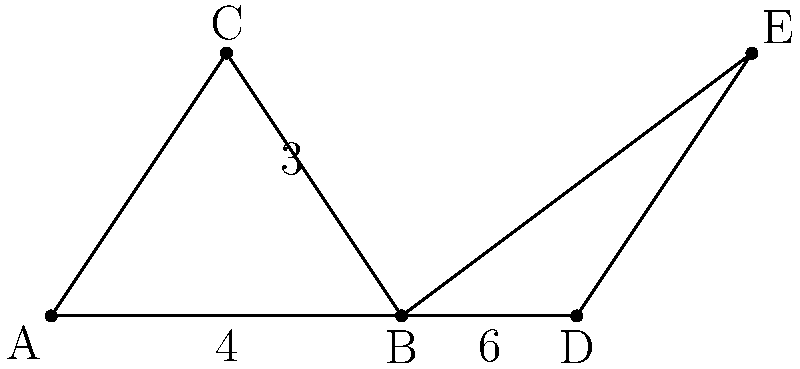During a practice session, you notice that your hockey sticks form two triangles on the ice as shown in the diagram. Triangle ABC and triangle BDE share a common base angle at point B. If AB = 4 units, BC = 3 units, and BD = 6 units, are these triangles congruent? If so, state the congruence criterion. Let's approach this step-by-step:

1) First, we need to determine if these triangles are congruent. For this, we need to check if they satisfy any of the congruence criteria: SSS, SAS, ASA, or AAS.

2) We're given that:
   - AB = 4 units
   - BC = 3 units
   - BD = 6 units
   - Angle B is common to both triangles

3) We don't have enough information about all sides or all angles. However, we can use the given information to prove that these triangles are similar, and then check if they're congruent.

4) The triangles share an angle at B, and both have a right angle (one at A, one at D). Two angles being equal means the triangles are similar.

5) For similar triangles, the ratio of corresponding sides is constant. Let's call this ratio r.

   $r = \frac{BD}{AB} = \frac{6}{4} = 1.5$

6) If the triangles are congruent, this ratio should be 1. Since it's 1.5, the triangles are not congruent.

7) We can confirm this by calculating BE:
   $BE = BC * r = 3 * 1.5 = 4.5$ units

   BE is longer than BC, confirming that the triangles are not congruent.
Answer: No, not congruent 